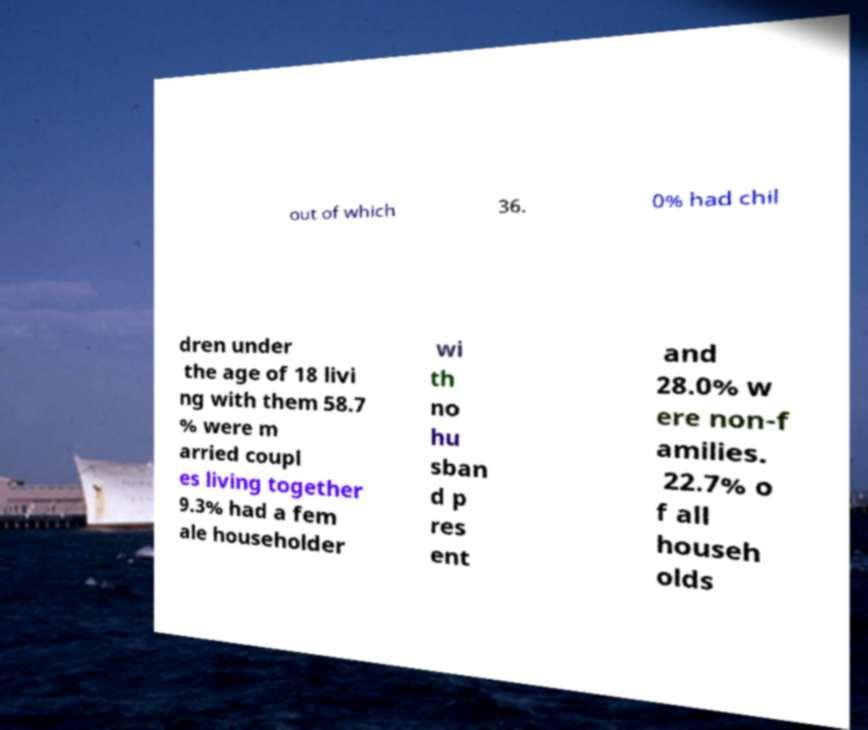I need the written content from this picture converted into text. Can you do that? out of which 36. 0% had chil dren under the age of 18 livi ng with them 58.7 % were m arried coupl es living together 9.3% had a fem ale householder wi th no hu sban d p res ent and 28.0% w ere non-f amilies. 22.7% o f all househ olds 